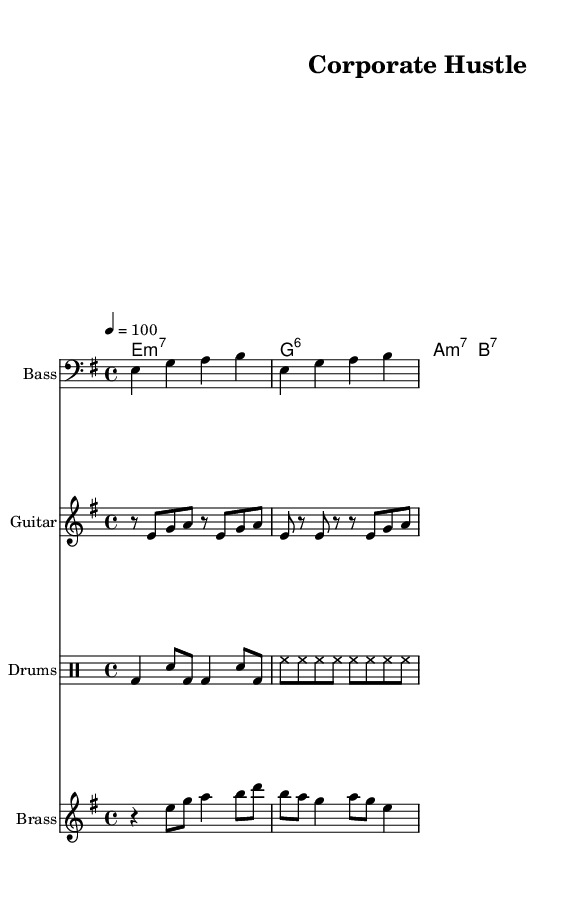What is the key signature of this music? The key signature is E minor, which has one sharp (F#). This can be identified from the key signature marking at the beginning of the first staff.
Answer: E minor What is the time signature of this music? The time signature is 4/4, which can be seen at the start of the score where it indicates four beats per measure.
Answer: 4/4 What is the tempo marking of this music? The tempo marking indicates a tempo of 100 beats per minute, as shown by the numerical indication following the word "tempo."
Answer: 100 How many bars are in the bass line? The bass line has four bars, as indicated by the grouping of notes divided by vertical bar lines.
Answer: Four Which instrument plays the main rhythm in this piece? The drums are played in a rhythmic pattern that provides the main groove for the piece, as indicated by the drum staff.
Answer: Drums What chord follows the C minor 7 chord in the progression? The chord progression shows that after C minor 7, the next chord is E minor 7, as seen in the chord mode part of the score.
Answer: E minor 7 What is the primary theme of this composition? The primary theme revolves around corporate competition and business rivalry, which can be inferred from the title "Corporate Hustle."
Answer: Corporate competition 